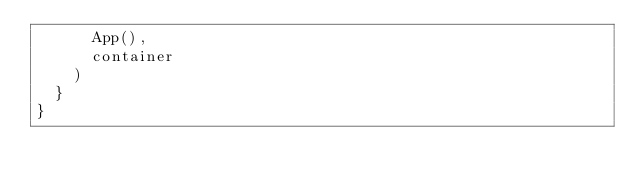Convert code to text. <code><loc_0><loc_0><loc_500><loc_500><_Scala_>      App(),
      container
    )
  }
}
</code> 